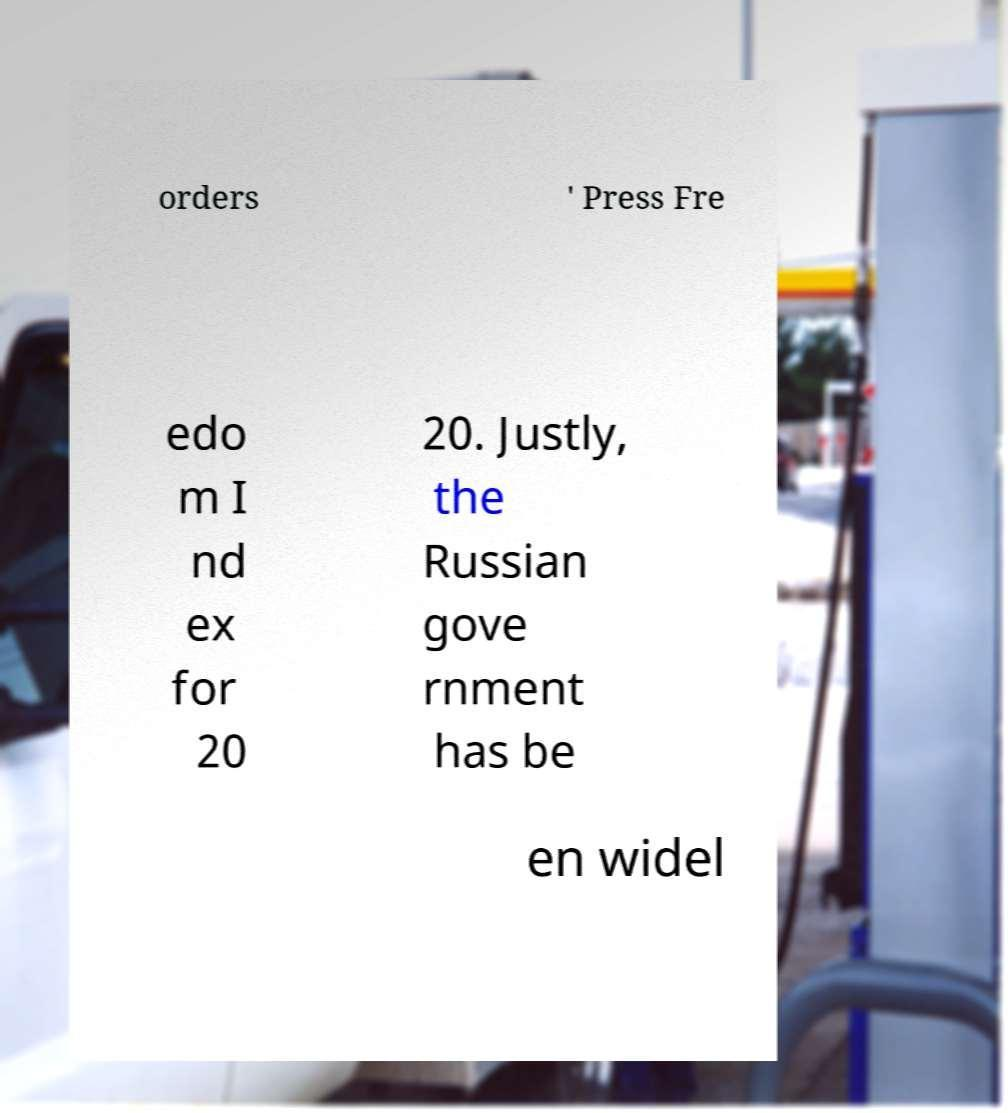For documentation purposes, I need the text within this image transcribed. Could you provide that? orders ' Press Fre edo m I nd ex for 20 20. Justly, the Russian gove rnment has be en widel 